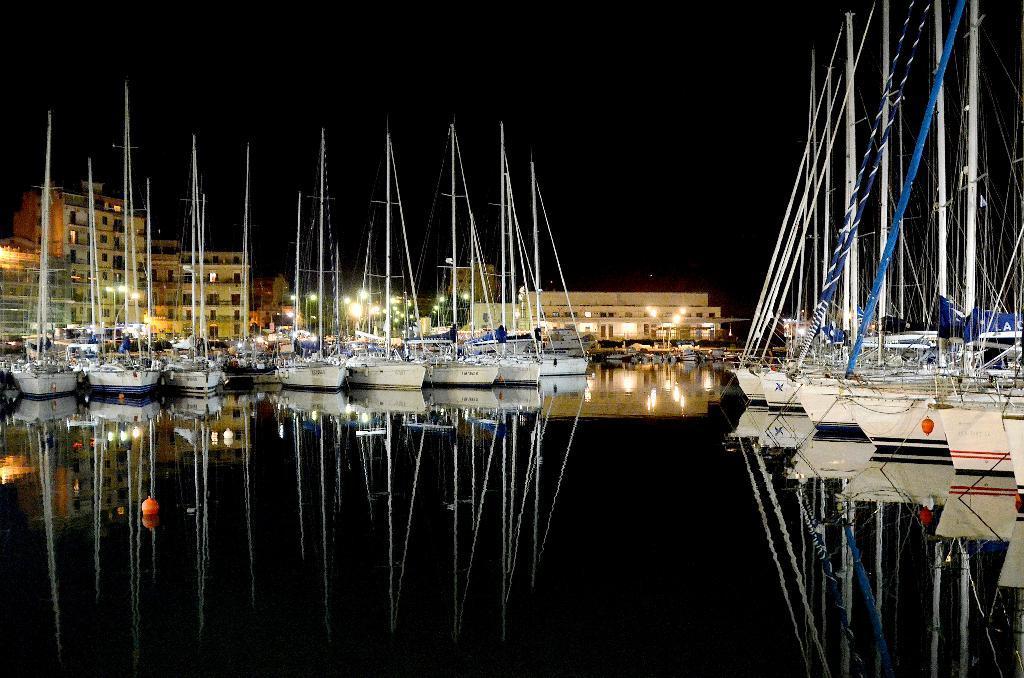Could you give a brief overview of what you see in this image? Above this water there are boats. Background there are buildings and lights This is dark sky. On this water there is a reflection of buildings, lights and boats. 